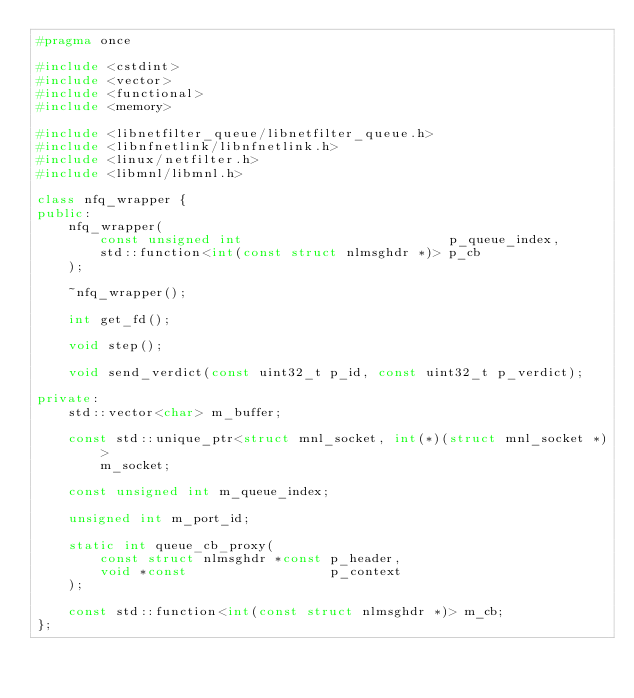<code> <loc_0><loc_0><loc_500><loc_500><_C++_>#pragma once

#include <cstdint>
#include <vector>
#include <functional>
#include <memory>

#include <libnetfilter_queue/libnetfilter_queue.h>
#include <libnfnetlink/libnfnetlink.h>
#include <linux/netfilter.h>
#include <libmnl/libmnl.h>

class nfq_wrapper {
public:
    nfq_wrapper(
        const unsigned int                          p_queue_index,
        std::function<int(const struct nlmsghdr *)> p_cb
    );

    ~nfq_wrapper();

    int get_fd();

    void step();

    void send_verdict(const uint32_t p_id, const uint32_t p_verdict);

private:
    std::vector<char> m_buffer;

    const std::unique_ptr<struct mnl_socket, int(*)(struct mnl_socket *)>
        m_socket;

    const unsigned int m_queue_index;

    unsigned int m_port_id;

    static int queue_cb_proxy(
        const struct nlmsghdr *const p_header,
        void *const                  p_context
    );

    const std::function<int(const struct nlmsghdr *)> m_cb;
};
</code> 